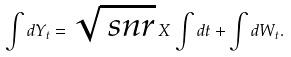Convert formula to latex. <formula><loc_0><loc_0><loc_500><loc_500>\int d Y _ { t } = \sqrt { \ s n r } \, X \, \int d t + \int d W _ { t } .</formula> 